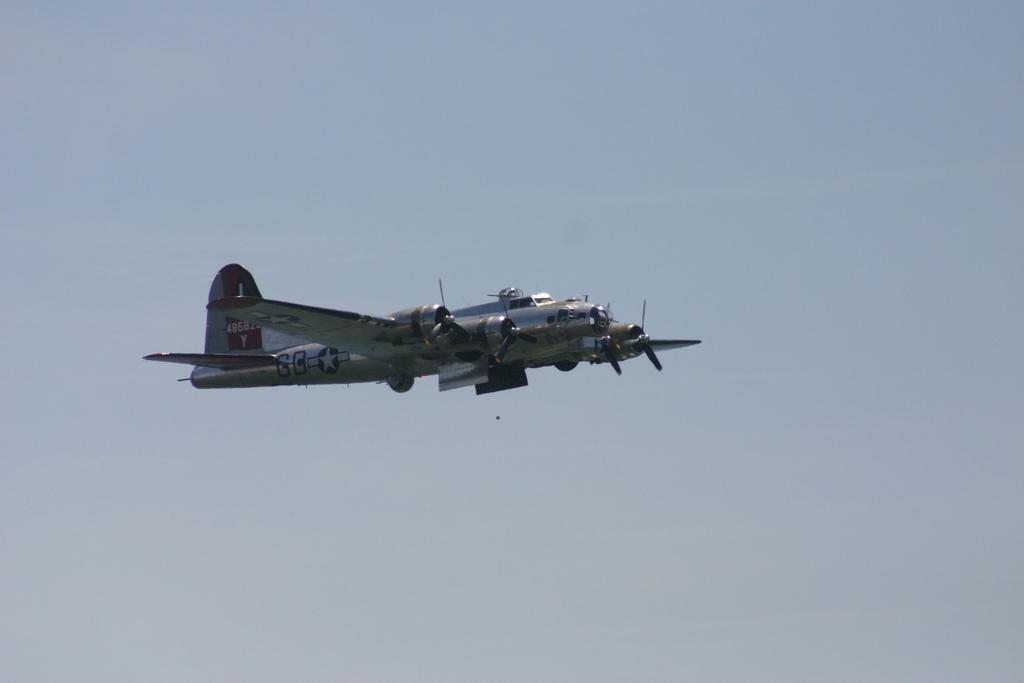What number is in red on the plane?
Provide a short and direct response. 4858. 